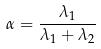<formula> <loc_0><loc_0><loc_500><loc_500>\alpha = \frac { \lambda _ { 1 } } { \lambda _ { 1 } + \lambda _ { 2 } }</formula> 